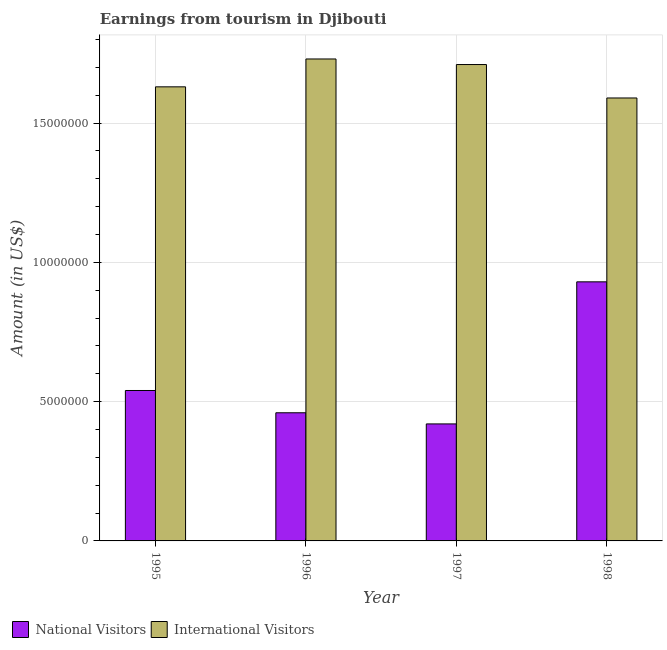How many different coloured bars are there?
Give a very brief answer. 2. How many groups of bars are there?
Keep it short and to the point. 4. How many bars are there on the 3rd tick from the left?
Offer a very short reply. 2. How many bars are there on the 1st tick from the right?
Ensure brevity in your answer.  2. What is the label of the 1st group of bars from the left?
Make the answer very short. 1995. What is the amount earned from national visitors in 1997?
Your answer should be compact. 4.20e+06. Across all years, what is the maximum amount earned from national visitors?
Keep it short and to the point. 9.30e+06. Across all years, what is the minimum amount earned from international visitors?
Your answer should be very brief. 1.59e+07. In which year was the amount earned from national visitors maximum?
Provide a short and direct response. 1998. What is the total amount earned from international visitors in the graph?
Offer a very short reply. 6.66e+07. What is the difference between the amount earned from international visitors in 1997 and that in 1998?
Ensure brevity in your answer.  1.20e+06. What is the difference between the amount earned from national visitors in 1996 and the amount earned from international visitors in 1998?
Make the answer very short. -4.70e+06. What is the average amount earned from international visitors per year?
Provide a short and direct response. 1.66e+07. In the year 1996, what is the difference between the amount earned from international visitors and amount earned from national visitors?
Your response must be concise. 0. In how many years, is the amount earned from international visitors greater than 17000000 US$?
Ensure brevity in your answer.  2. What is the ratio of the amount earned from national visitors in 1995 to that in 1998?
Provide a short and direct response. 0.58. Is the amount earned from international visitors in 1996 less than that in 1998?
Ensure brevity in your answer.  No. Is the difference between the amount earned from national visitors in 1997 and 1998 greater than the difference between the amount earned from international visitors in 1997 and 1998?
Keep it short and to the point. No. What is the difference between the highest and the second highest amount earned from national visitors?
Provide a succinct answer. 3.90e+06. What is the difference between the highest and the lowest amount earned from international visitors?
Give a very brief answer. 1.40e+06. In how many years, is the amount earned from national visitors greater than the average amount earned from national visitors taken over all years?
Provide a succinct answer. 1. What does the 1st bar from the left in 1995 represents?
Provide a succinct answer. National Visitors. What does the 1st bar from the right in 1997 represents?
Ensure brevity in your answer.  International Visitors. How many bars are there?
Keep it short and to the point. 8. Are all the bars in the graph horizontal?
Ensure brevity in your answer.  No. How many years are there in the graph?
Keep it short and to the point. 4. What is the difference between two consecutive major ticks on the Y-axis?
Your response must be concise. 5.00e+06. Are the values on the major ticks of Y-axis written in scientific E-notation?
Provide a short and direct response. No. Does the graph contain any zero values?
Keep it short and to the point. No. Does the graph contain grids?
Offer a very short reply. Yes. What is the title of the graph?
Provide a succinct answer. Earnings from tourism in Djibouti. What is the label or title of the X-axis?
Make the answer very short. Year. What is the Amount (in US$) in National Visitors in 1995?
Provide a succinct answer. 5.40e+06. What is the Amount (in US$) in International Visitors in 1995?
Your answer should be very brief. 1.63e+07. What is the Amount (in US$) in National Visitors in 1996?
Offer a terse response. 4.60e+06. What is the Amount (in US$) of International Visitors in 1996?
Your answer should be very brief. 1.73e+07. What is the Amount (in US$) in National Visitors in 1997?
Provide a succinct answer. 4.20e+06. What is the Amount (in US$) of International Visitors in 1997?
Make the answer very short. 1.71e+07. What is the Amount (in US$) in National Visitors in 1998?
Your response must be concise. 9.30e+06. What is the Amount (in US$) in International Visitors in 1998?
Provide a succinct answer. 1.59e+07. Across all years, what is the maximum Amount (in US$) of National Visitors?
Keep it short and to the point. 9.30e+06. Across all years, what is the maximum Amount (in US$) in International Visitors?
Make the answer very short. 1.73e+07. Across all years, what is the minimum Amount (in US$) of National Visitors?
Ensure brevity in your answer.  4.20e+06. Across all years, what is the minimum Amount (in US$) of International Visitors?
Give a very brief answer. 1.59e+07. What is the total Amount (in US$) in National Visitors in the graph?
Offer a very short reply. 2.35e+07. What is the total Amount (in US$) in International Visitors in the graph?
Give a very brief answer. 6.66e+07. What is the difference between the Amount (in US$) in International Visitors in 1995 and that in 1996?
Provide a short and direct response. -1.00e+06. What is the difference between the Amount (in US$) of National Visitors in 1995 and that in 1997?
Provide a succinct answer. 1.20e+06. What is the difference between the Amount (in US$) in International Visitors in 1995 and that in 1997?
Your response must be concise. -8.00e+05. What is the difference between the Amount (in US$) in National Visitors in 1995 and that in 1998?
Keep it short and to the point. -3.90e+06. What is the difference between the Amount (in US$) in National Visitors in 1996 and that in 1997?
Provide a succinct answer. 4.00e+05. What is the difference between the Amount (in US$) in International Visitors in 1996 and that in 1997?
Your answer should be very brief. 2.00e+05. What is the difference between the Amount (in US$) of National Visitors in 1996 and that in 1998?
Offer a very short reply. -4.70e+06. What is the difference between the Amount (in US$) in International Visitors in 1996 and that in 1998?
Keep it short and to the point. 1.40e+06. What is the difference between the Amount (in US$) of National Visitors in 1997 and that in 1998?
Offer a terse response. -5.10e+06. What is the difference between the Amount (in US$) in International Visitors in 1997 and that in 1998?
Offer a very short reply. 1.20e+06. What is the difference between the Amount (in US$) of National Visitors in 1995 and the Amount (in US$) of International Visitors in 1996?
Ensure brevity in your answer.  -1.19e+07. What is the difference between the Amount (in US$) of National Visitors in 1995 and the Amount (in US$) of International Visitors in 1997?
Ensure brevity in your answer.  -1.17e+07. What is the difference between the Amount (in US$) in National Visitors in 1995 and the Amount (in US$) in International Visitors in 1998?
Provide a succinct answer. -1.05e+07. What is the difference between the Amount (in US$) of National Visitors in 1996 and the Amount (in US$) of International Visitors in 1997?
Your answer should be compact. -1.25e+07. What is the difference between the Amount (in US$) of National Visitors in 1996 and the Amount (in US$) of International Visitors in 1998?
Your answer should be compact. -1.13e+07. What is the difference between the Amount (in US$) of National Visitors in 1997 and the Amount (in US$) of International Visitors in 1998?
Provide a short and direct response. -1.17e+07. What is the average Amount (in US$) in National Visitors per year?
Your answer should be very brief. 5.88e+06. What is the average Amount (in US$) in International Visitors per year?
Make the answer very short. 1.66e+07. In the year 1995, what is the difference between the Amount (in US$) of National Visitors and Amount (in US$) of International Visitors?
Provide a short and direct response. -1.09e+07. In the year 1996, what is the difference between the Amount (in US$) of National Visitors and Amount (in US$) of International Visitors?
Your answer should be very brief. -1.27e+07. In the year 1997, what is the difference between the Amount (in US$) of National Visitors and Amount (in US$) of International Visitors?
Keep it short and to the point. -1.29e+07. In the year 1998, what is the difference between the Amount (in US$) of National Visitors and Amount (in US$) of International Visitors?
Provide a succinct answer. -6.60e+06. What is the ratio of the Amount (in US$) in National Visitors in 1995 to that in 1996?
Provide a short and direct response. 1.17. What is the ratio of the Amount (in US$) in International Visitors in 1995 to that in 1996?
Your answer should be compact. 0.94. What is the ratio of the Amount (in US$) of International Visitors in 1995 to that in 1997?
Make the answer very short. 0.95. What is the ratio of the Amount (in US$) of National Visitors in 1995 to that in 1998?
Provide a short and direct response. 0.58. What is the ratio of the Amount (in US$) in International Visitors in 1995 to that in 1998?
Give a very brief answer. 1.03. What is the ratio of the Amount (in US$) of National Visitors in 1996 to that in 1997?
Provide a succinct answer. 1.1. What is the ratio of the Amount (in US$) of International Visitors in 1996 to that in 1997?
Keep it short and to the point. 1.01. What is the ratio of the Amount (in US$) in National Visitors in 1996 to that in 1998?
Your response must be concise. 0.49. What is the ratio of the Amount (in US$) in International Visitors in 1996 to that in 1998?
Provide a succinct answer. 1.09. What is the ratio of the Amount (in US$) in National Visitors in 1997 to that in 1998?
Offer a very short reply. 0.45. What is the ratio of the Amount (in US$) in International Visitors in 1997 to that in 1998?
Provide a succinct answer. 1.08. What is the difference between the highest and the second highest Amount (in US$) of National Visitors?
Make the answer very short. 3.90e+06. What is the difference between the highest and the lowest Amount (in US$) in National Visitors?
Provide a short and direct response. 5.10e+06. What is the difference between the highest and the lowest Amount (in US$) of International Visitors?
Make the answer very short. 1.40e+06. 